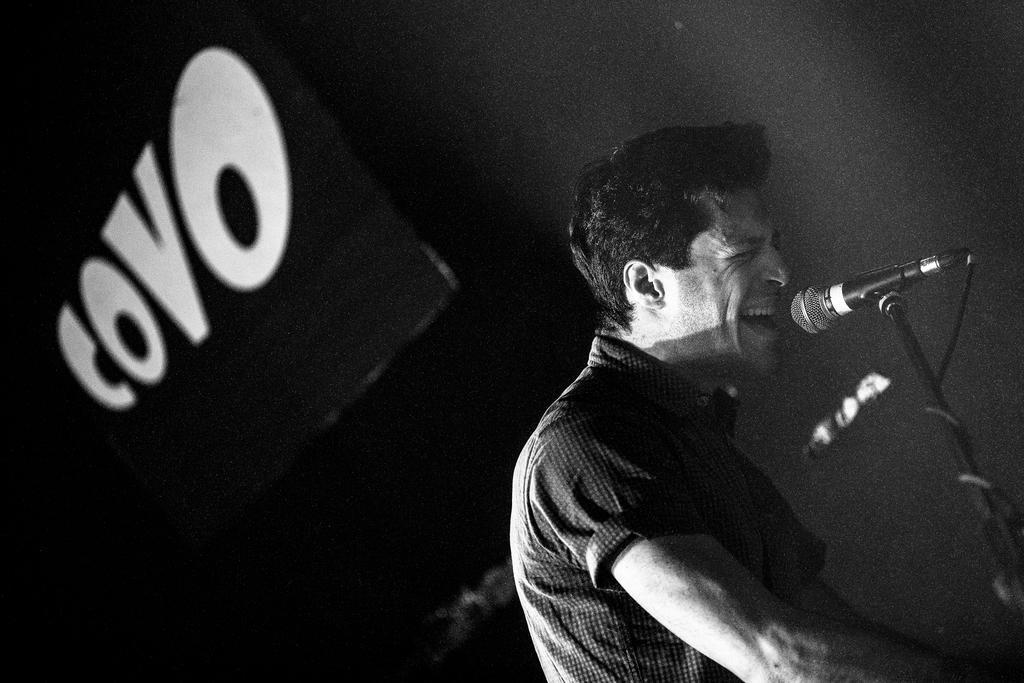Who is the main subject in the image? There is a man in the image. What is the man doing in the image? The man is singing in the image. What object is in front of the man? There is a microphone in front of the man. How much income does the snow receive for its performance in the image? There is no snow present in the image, and therefore no income can be attributed to it. 